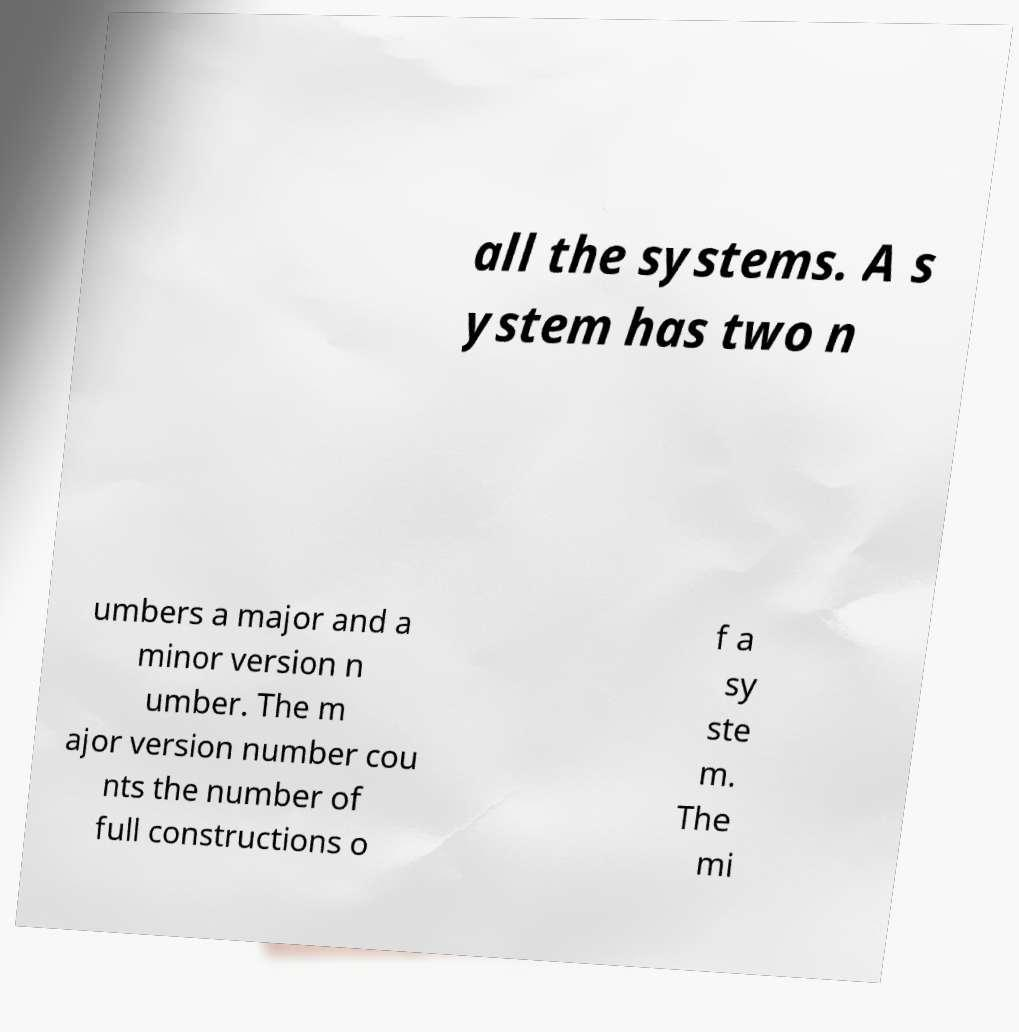Can you accurately transcribe the text from the provided image for me? all the systems. A s ystem has two n umbers a major and a minor version n umber. The m ajor version number cou nts the number of full constructions o f a sy ste m. The mi 